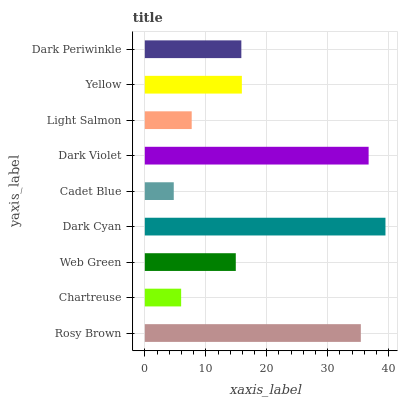Is Cadet Blue the minimum?
Answer yes or no. Yes. Is Dark Cyan the maximum?
Answer yes or no. Yes. Is Chartreuse the minimum?
Answer yes or no. No. Is Chartreuse the maximum?
Answer yes or no. No. Is Rosy Brown greater than Chartreuse?
Answer yes or no. Yes. Is Chartreuse less than Rosy Brown?
Answer yes or no. Yes. Is Chartreuse greater than Rosy Brown?
Answer yes or no. No. Is Rosy Brown less than Chartreuse?
Answer yes or no. No. Is Dark Periwinkle the high median?
Answer yes or no. Yes. Is Dark Periwinkle the low median?
Answer yes or no. Yes. Is Dark Violet the high median?
Answer yes or no. No. Is Dark Violet the low median?
Answer yes or no. No. 